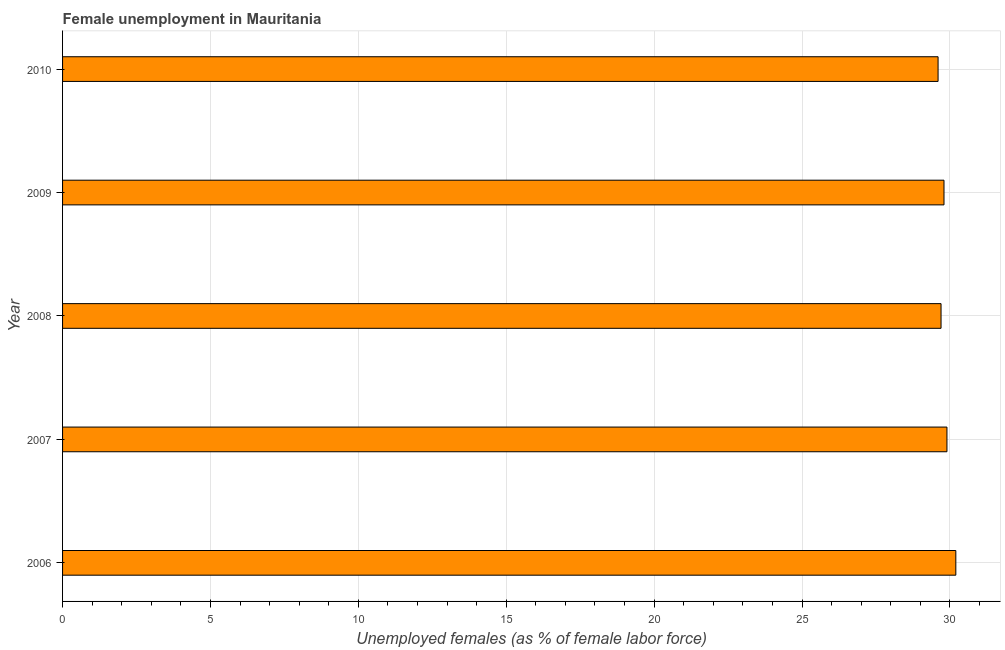Does the graph contain any zero values?
Give a very brief answer. No. Does the graph contain grids?
Offer a very short reply. Yes. What is the title of the graph?
Your response must be concise. Female unemployment in Mauritania. What is the label or title of the X-axis?
Your answer should be compact. Unemployed females (as % of female labor force). What is the label or title of the Y-axis?
Your answer should be very brief. Year. What is the unemployed females population in 2007?
Your response must be concise. 29.9. Across all years, what is the maximum unemployed females population?
Your response must be concise. 30.2. Across all years, what is the minimum unemployed females population?
Your answer should be very brief. 29.6. In which year was the unemployed females population maximum?
Your answer should be very brief. 2006. What is the sum of the unemployed females population?
Your answer should be compact. 149.2. What is the difference between the unemployed females population in 2006 and 2009?
Provide a succinct answer. 0.4. What is the average unemployed females population per year?
Give a very brief answer. 29.84. What is the median unemployed females population?
Your answer should be compact. 29.8. In how many years, is the unemployed females population greater than 8 %?
Keep it short and to the point. 5. Do a majority of the years between 2008 and 2007 (inclusive) have unemployed females population greater than 28 %?
Provide a short and direct response. No. Is the unemployed females population in 2008 less than that in 2009?
Ensure brevity in your answer.  Yes. What is the difference between the highest and the lowest unemployed females population?
Your response must be concise. 0.6. In how many years, is the unemployed females population greater than the average unemployed females population taken over all years?
Offer a very short reply. 2. Are the values on the major ticks of X-axis written in scientific E-notation?
Keep it short and to the point. No. What is the Unemployed females (as % of female labor force) of 2006?
Your response must be concise. 30.2. What is the Unemployed females (as % of female labor force) of 2007?
Keep it short and to the point. 29.9. What is the Unemployed females (as % of female labor force) of 2008?
Your answer should be very brief. 29.7. What is the Unemployed females (as % of female labor force) of 2009?
Your response must be concise. 29.8. What is the Unemployed females (as % of female labor force) in 2010?
Your answer should be very brief. 29.6. What is the difference between the Unemployed females (as % of female labor force) in 2006 and 2009?
Ensure brevity in your answer.  0.4. What is the difference between the Unemployed females (as % of female labor force) in 2006 and 2010?
Your answer should be very brief. 0.6. What is the difference between the Unemployed females (as % of female labor force) in 2007 and 2008?
Give a very brief answer. 0.2. What is the difference between the Unemployed females (as % of female labor force) in 2007 and 2009?
Give a very brief answer. 0.1. What is the difference between the Unemployed females (as % of female labor force) in 2007 and 2010?
Provide a succinct answer. 0.3. What is the difference between the Unemployed females (as % of female labor force) in 2008 and 2010?
Offer a terse response. 0.1. What is the difference between the Unemployed females (as % of female labor force) in 2009 and 2010?
Make the answer very short. 0.2. What is the ratio of the Unemployed females (as % of female labor force) in 2007 to that in 2009?
Provide a short and direct response. 1. What is the ratio of the Unemployed females (as % of female labor force) in 2008 to that in 2009?
Your response must be concise. 1. What is the ratio of the Unemployed females (as % of female labor force) in 2008 to that in 2010?
Give a very brief answer. 1. What is the ratio of the Unemployed females (as % of female labor force) in 2009 to that in 2010?
Your answer should be very brief. 1.01. 